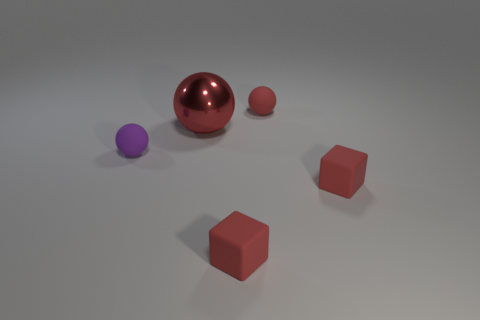Subtract all red shiny balls. How many balls are left? 2 Subtract all red blocks. How many red balls are left? 2 Subtract 1 balls. How many balls are left? 2 Add 1 tiny red rubber blocks. How many objects exist? 6 Subtract all brown balls. Subtract all red cylinders. How many balls are left? 3 Subtract all spheres. How many objects are left? 2 Subtract all large blue metallic things. Subtract all purple matte spheres. How many objects are left? 4 Add 2 tiny blocks. How many tiny blocks are left? 4 Add 4 small purple objects. How many small purple objects exist? 5 Subtract 0 gray balls. How many objects are left? 5 